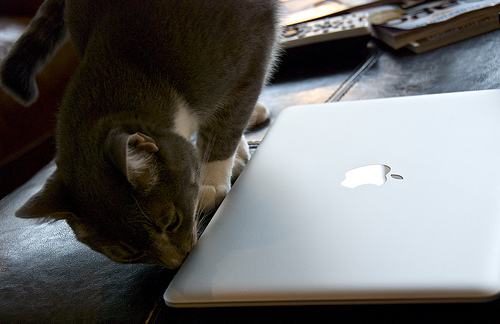Can you describe the setting where the laptop is placed? The laptop is placed on a flat, dark surface that resembles a leather couch or a cushioned bench. The environment emits a cozy, domestic feel, suggestive of a living room or a relaxed working space at home. 